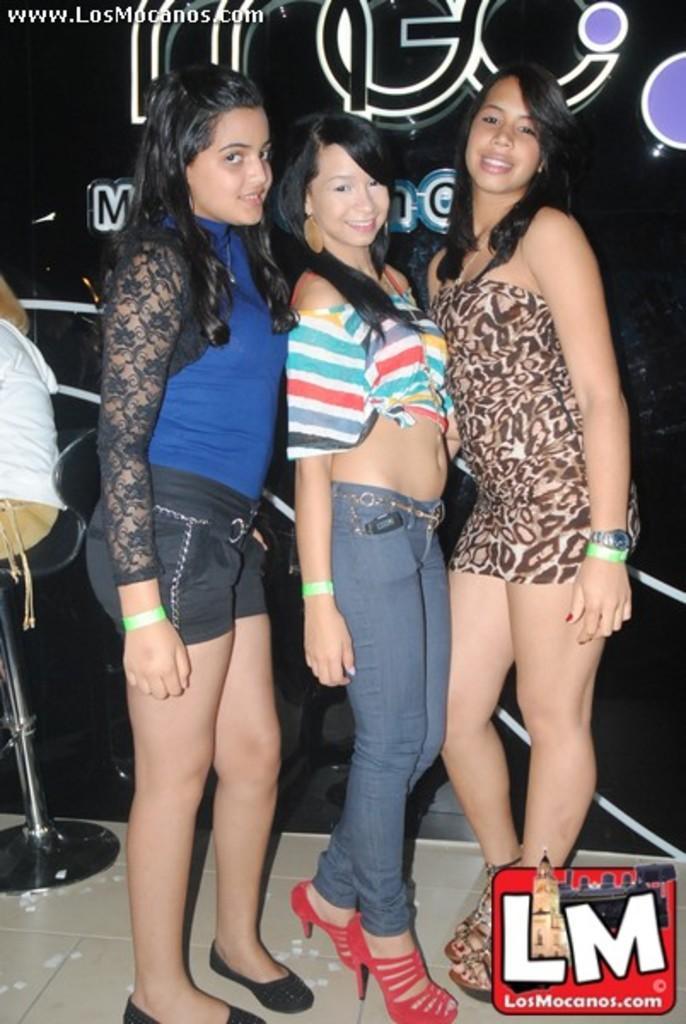In one or two sentences, can you explain what this image depicts? In this image I can see three women are standing and smiling. In the background I can see the black colored surface and a person wearing white shirt and brown pant is sitting on a chair. 